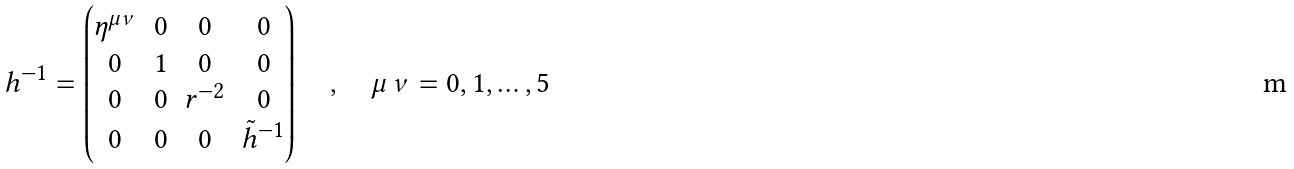<formula> <loc_0><loc_0><loc_500><loc_500>h ^ { - 1 } = \begin{pmatrix} \eta ^ { \mu \nu } & 0 & 0 & 0 \\ 0 & 1 & 0 & 0 \\ 0 & 0 & r ^ { - 2 } & 0 \\ 0 & 0 & 0 & \tilde { h } ^ { - 1 } \end{pmatrix} \quad , \quad \mu \, \nu = 0 , 1 , \dots , 5</formula> 